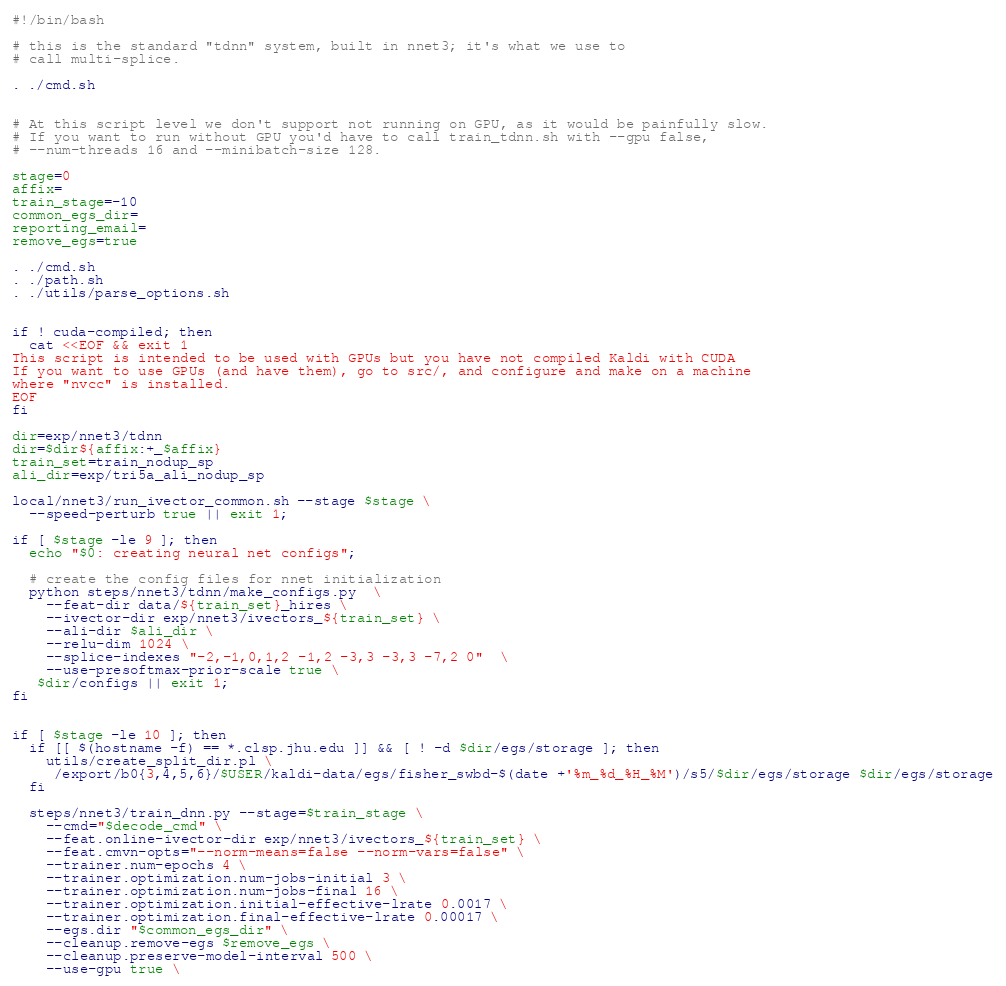Convert code to text. <code><loc_0><loc_0><loc_500><loc_500><_Bash_>#!/bin/bash

# this is the standard "tdnn" system, built in nnet3; it's what we use to
# call multi-splice.

. ./cmd.sh


# At this script level we don't support not running on GPU, as it would be painfully slow.
# If you want to run without GPU you'd have to call train_tdnn.sh with --gpu false,
# --num-threads 16 and --minibatch-size 128.

stage=0
affix=
train_stage=-10
common_egs_dir=
reporting_email=
remove_egs=true

. ./cmd.sh
. ./path.sh
. ./utils/parse_options.sh


if ! cuda-compiled; then
  cat <<EOF && exit 1
This script is intended to be used with GPUs but you have not compiled Kaldi with CUDA
If you want to use GPUs (and have them), go to src/, and configure and make on a machine
where "nvcc" is installed.
EOF
fi

dir=exp/nnet3/tdnn
dir=$dir${affix:+_$affix}
train_set=train_nodup_sp
ali_dir=exp/tri5a_ali_nodup_sp

local/nnet3/run_ivector_common.sh --stage $stage \
  --speed-perturb true || exit 1;

if [ $stage -le 9 ]; then
  echo "$0: creating neural net configs";

  # create the config files for nnet initialization
  python steps/nnet3/tdnn/make_configs.py  \
    --feat-dir data/${train_set}_hires \
    --ivector-dir exp/nnet3/ivectors_${train_set} \
    --ali-dir $ali_dir \
    --relu-dim 1024 \
    --splice-indexes "-2,-1,0,1,2 -1,2 -3,3 -3,3 -7,2 0"  \
    --use-presoftmax-prior-scale true \
   $dir/configs || exit 1;
fi


if [ $stage -le 10 ]; then
  if [[ $(hostname -f) == *.clsp.jhu.edu ]] && [ ! -d $dir/egs/storage ]; then
    utils/create_split_dir.pl \
     /export/b0{3,4,5,6}/$USER/kaldi-data/egs/fisher_swbd-$(date +'%m_%d_%H_%M')/s5/$dir/egs/storage $dir/egs/storage
  fi

  steps/nnet3/train_dnn.py --stage=$train_stage \
    --cmd="$decode_cmd" \
    --feat.online-ivector-dir exp/nnet3/ivectors_${train_set} \
    --feat.cmvn-opts="--norm-means=false --norm-vars=false" \
    --trainer.num-epochs 4 \
    --trainer.optimization.num-jobs-initial 3 \
    --trainer.optimization.num-jobs-final 16 \
    --trainer.optimization.initial-effective-lrate 0.0017 \
    --trainer.optimization.final-effective-lrate 0.00017 \
    --egs.dir "$common_egs_dir" \
    --cleanup.remove-egs $remove_egs \
    --cleanup.preserve-model-interval 500 \
    --use-gpu true \</code> 